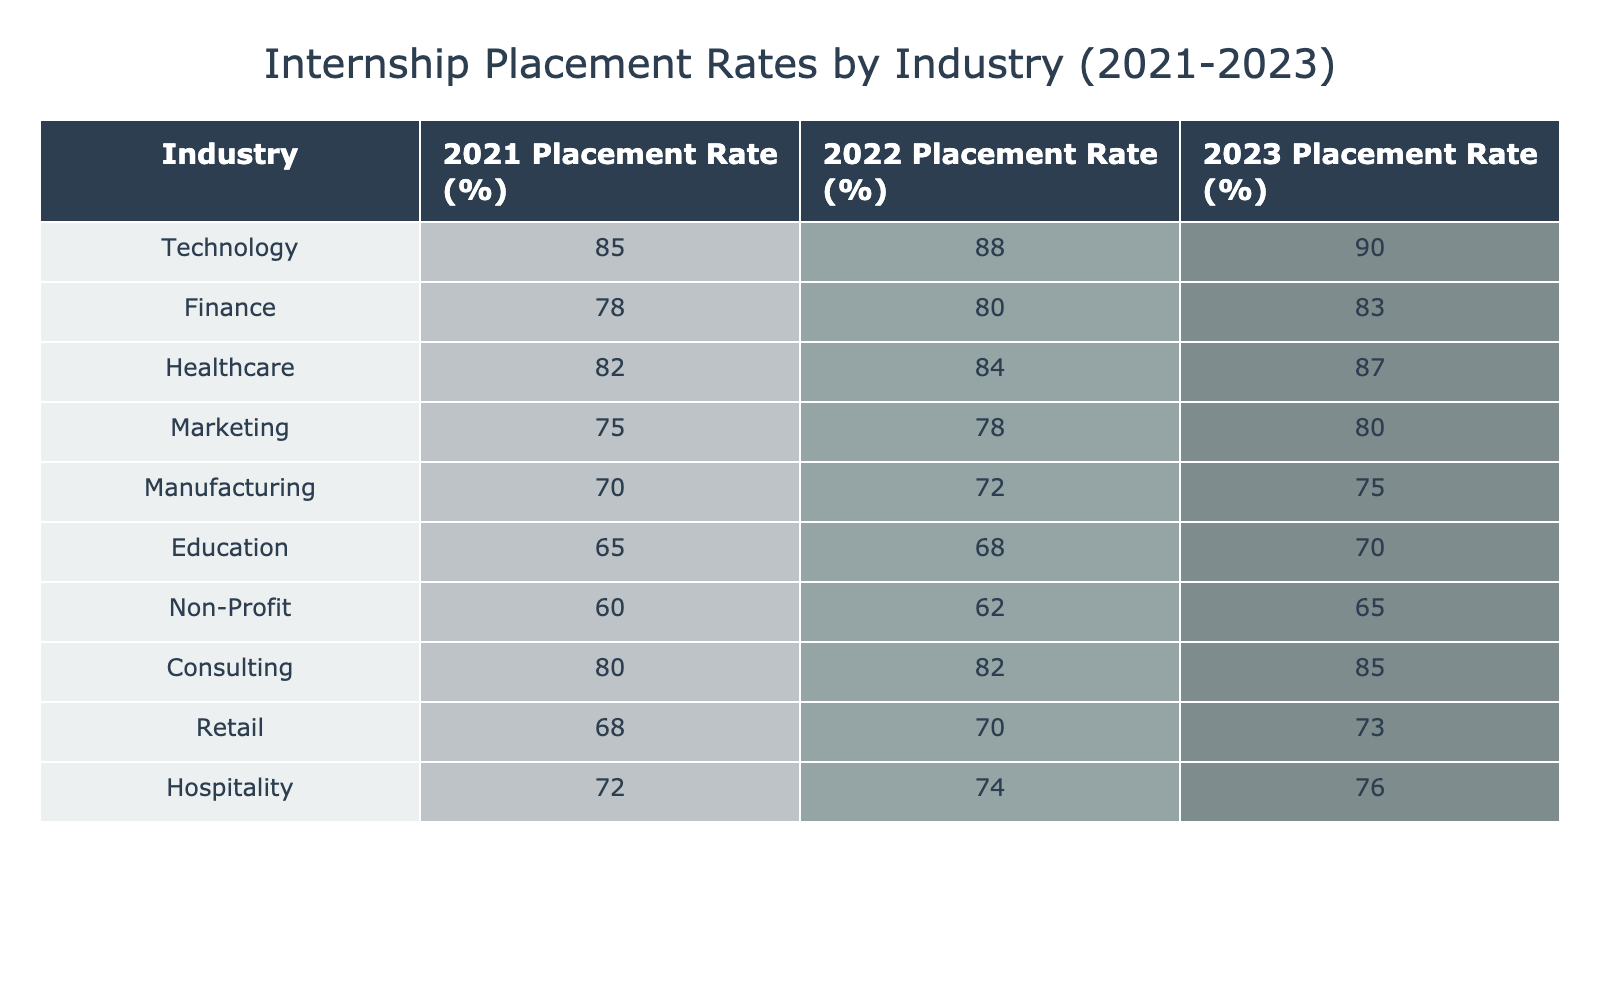What was the highest internship placement rate in 2023? The 2023 placement rates for all industries are listed in the table. The highest value is 90% for the Technology industry.
Answer: 90% What percentage of internships were placed in the Healthcare industry in 2022? The table shows that the placement rate for Healthcare in 2022 is 84%.
Answer: 84% Which industry had the lowest internship placement rate in 2021? By examining the placement rates for 2021, the Non-Profit industry had the lowest rate at 60%.
Answer: 60% What is the average placement rate for the Finance and Consulting industries over the three years? The placement rates are: Finance (78, 80, 83) and Consulting (80, 82, 85). The averages are (78+80+83)/3 = 80.33 for Finance and (80+82+85)/3 = 82.33 for Consulting. Adding these averages gives 80.33 + 82.33 = 162.66, and dividing by 2 gives an average of 81.33.
Answer: 81.33 Did the placement rate in the Retail industry increase every year from 2021 to 2023? The Retail placement rates are: 68% in 2021, 70% in 2022, and 73% in 2023. Since each year shows an increase, the answer is yes.
Answer: Yes What was the difference in placement rates between Education and Marketing industries in 2023? The placement rates in 2023 are: Education at 70% and Marketing at 80%. The difference is 80 - 70 = 10%.
Answer: 10% Which industry showed the most significant increase in placement rate from 2021 to 2023? By comparing the rates: Technology increased from 85% to 90% (+5), Finance from 78% to 83% (+5), Healthcare from 82% to 87% (+5), and others with smaller increases. The highest increase is 5% shared by these industries.
Answer: 5% How did the Healthcare industry's placement rate change from 2021 to 2023? The Healthcare placement rates were 82% in 2021 and increased to 87% in 2023, showing a change of 87 - 82 = 5%.
Answer: Increased by 5% Which two industries had the closest placement rates in 2022? The placement rates for 2022 were Finance (80) and Healthcare (84), with a difference of 4%. Other pairs had larger differences, making Finance and Healthcare the closest.
Answer: 4% 